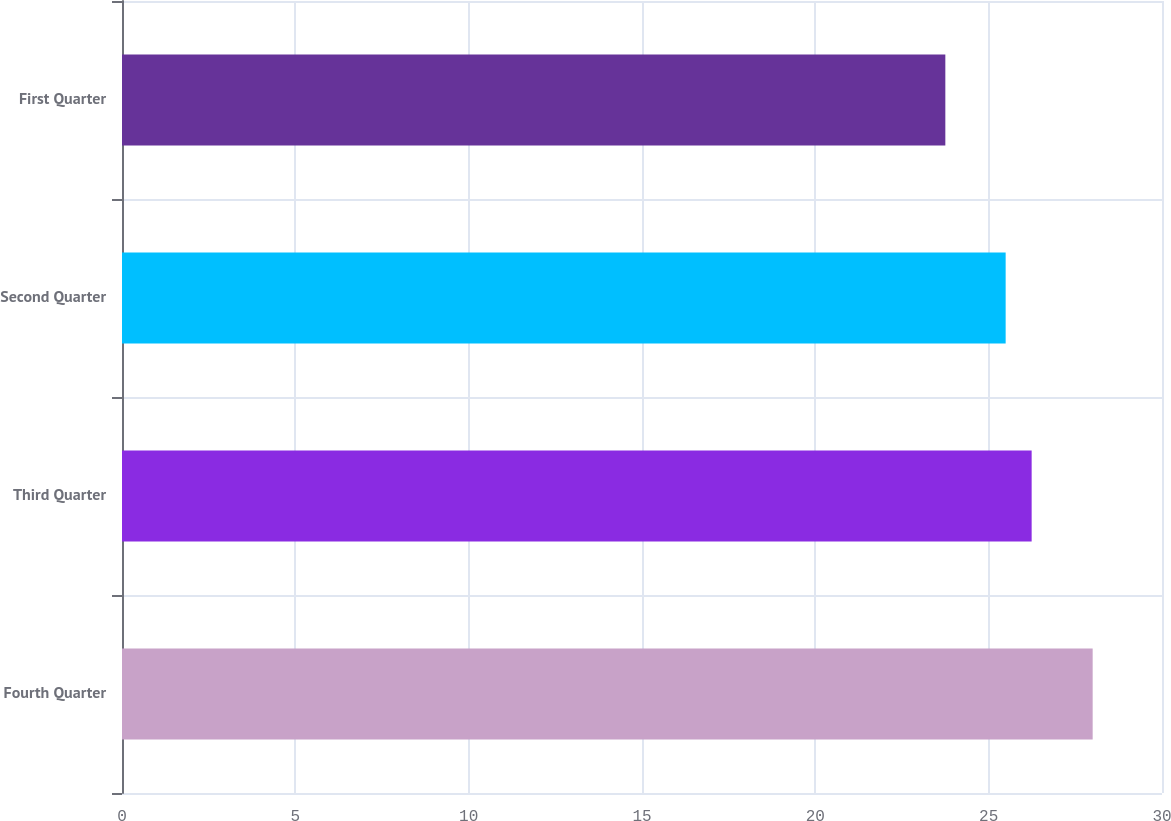Convert chart. <chart><loc_0><loc_0><loc_500><loc_500><bar_chart><fcel>Fourth Quarter<fcel>Third Quarter<fcel>Second Quarter<fcel>First Quarter<nl><fcel>28<fcel>26.24<fcel>25.49<fcel>23.75<nl></chart> 